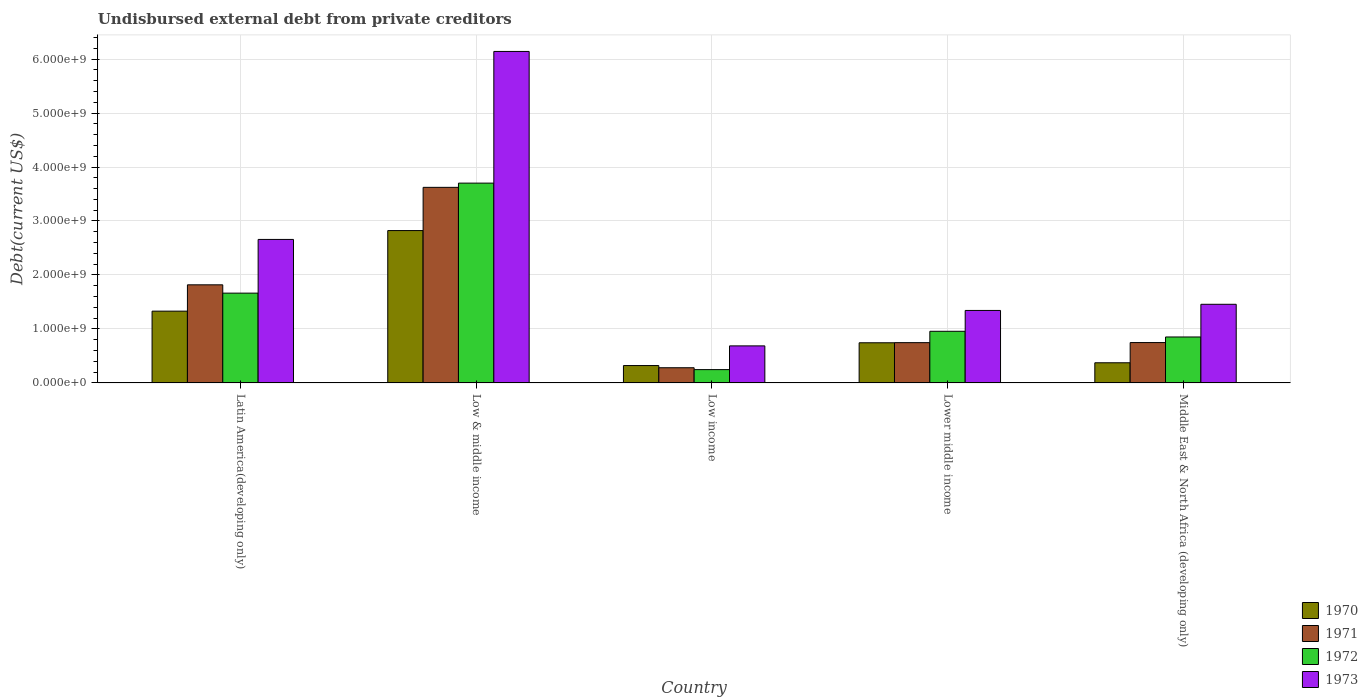How many different coloured bars are there?
Provide a succinct answer. 4. Are the number of bars per tick equal to the number of legend labels?
Your answer should be compact. Yes. How many bars are there on the 4th tick from the left?
Offer a very short reply. 4. What is the label of the 4th group of bars from the left?
Offer a terse response. Lower middle income. What is the total debt in 1971 in Middle East & North Africa (developing only)?
Your response must be concise. 7.48e+08. Across all countries, what is the maximum total debt in 1971?
Make the answer very short. 3.62e+09. Across all countries, what is the minimum total debt in 1972?
Offer a terse response. 2.47e+08. In which country was the total debt in 1970 maximum?
Make the answer very short. Low & middle income. What is the total total debt in 1972 in the graph?
Your answer should be compact. 7.42e+09. What is the difference between the total debt in 1973 in Low & middle income and that in Low income?
Your answer should be very brief. 5.45e+09. What is the difference between the total debt in 1972 in Middle East & North Africa (developing only) and the total debt in 1971 in Low & middle income?
Give a very brief answer. -2.77e+09. What is the average total debt in 1971 per country?
Provide a succinct answer. 1.44e+09. What is the difference between the total debt of/in 1971 and total debt of/in 1973 in Middle East & North Africa (developing only)?
Offer a very short reply. -7.09e+08. What is the ratio of the total debt in 1973 in Low & middle income to that in Lower middle income?
Offer a terse response. 4.57. Is the total debt in 1971 in Latin America(developing only) less than that in Low & middle income?
Your answer should be very brief. Yes. What is the difference between the highest and the second highest total debt in 1973?
Keep it short and to the point. -1.20e+09. What is the difference between the highest and the lowest total debt in 1973?
Keep it short and to the point. 5.45e+09. In how many countries, is the total debt in 1971 greater than the average total debt in 1971 taken over all countries?
Offer a very short reply. 2. Is it the case that in every country, the sum of the total debt in 1973 and total debt in 1971 is greater than the sum of total debt in 1972 and total debt in 1970?
Your answer should be compact. No. What does the 3rd bar from the left in Middle East & North Africa (developing only) represents?
Provide a short and direct response. 1972. What does the 1st bar from the right in Low income represents?
Offer a terse response. 1973. Is it the case that in every country, the sum of the total debt in 1970 and total debt in 1972 is greater than the total debt in 1971?
Make the answer very short. Yes. How many bars are there?
Ensure brevity in your answer.  20. How many countries are there in the graph?
Give a very brief answer. 5. What is the difference between two consecutive major ticks on the Y-axis?
Give a very brief answer. 1.00e+09. Are the values on the major ticks of Y-axis written in scientific E-notation?
Ensure brevity in your answer.  Yes. How are the legend labels stacked?
Provide a succinct answer. Vertical. What is the title of the graph?
Your response must be concise. Undisbursed external debt from private creditors. Does "1984" appear as one of the legend labels in the graph?
Provide a short and direct response. No. What is the label or title of the X-axis?
Your answer should be compact. Country. What is the label or title of the Y-axis?
Give a very brief answer. Debt(current US$). What is the Debt(current US$) in 1970 in Latin America(developing only)?
Your answer should be very brief. 1.33e+09. What is the Debt(current US$) of 1971 in Latin America(developing only)?
Offer a very short reply. 1.82e+09. What is the Debt(current US$) in 1972 in Latin America(developing only)?
Keep it short and to the point. 1.66e+09. What is the Debt(current US$) in 1973 in Latin America(developing only)?
Keep it short and to the point. 2.66e+09. What is the Debt(current US$) in 1970 in Low & middle income?
Offer a very short reply. 2.82e+09. What is the Debt(current US$) of 1971 in Low & middle income?
Offer a terse response. 3.62e+09. What is the Debt(current US$) of 1972 in Low & middle income?
Provide a short and direct response. 3.70e+09. What is the Debt(current US$) of 1973 in Low & middle income?
Keep it short and to the point. 6.14e+09. What is the Debt(current US$) in 1970 in Low income?
Offer a terse response. 3.22e+08. What is the Debt(current US$) of 1971 in Low income?
Keep it short and to the point. 2.82e+08. What is the Debt(current US$) in 1972 in Low income?
Provide a succinct answer. 2.47e+08. What is the Debt(current US$) in 1973 in Low income?
Your response must be concise. 6.86e+08. What is the Debt(current US$) of 1970 in Lower middle income?
Your response must be concise. 7.44e+08. What is the Debt(current US$) of 1971 in Lower middle income?
Offer a terse response. 7.46e+08. What is the Debt(current US$) of 1972 in Lower middle income?
Provide a succinct answer. 9.57e+08. What is the Debt(current US$) in 1973 in Lower middle income?
Your response must be concise. 1.34e+09. What is the Debt(current US$) in 1970 in Middle East & North Africa (developing only)?
Make the answer very short. 3.74e+08. What is the Debt(current US$) in 1971 in Middle East & North Africa (developing only)?
Provide a short and direct response. 7.48e+08. What is the Debt(current US$) of 1972 in Middle East & North Africa (developing only)?
Ensure brevity in your answer.  8.51e+08. What is the Debt(current US$) in 1973 in Middle East & North Africa (developing only)?
Make the answer very short. 1.46e+09. Across all countries, what is the maximum Debt(current US$) of 1970?
Your response must be concise. 2.82e+09. Across all countries, what is the maximum Debt(current US$) in 1971?
Provide a short and direct response. 3.62e+09. Across all countries, what is the maximum Debt(current US$) of 1972?
Your answer should be very brief. 3.70e+09. Across all countries, what is the maximum Debt(current US$) in 1973?
Ensure brevity in your answer.  6.14e+09. Across all countries, what is the minimum Debt(current US$) in 1970?
Offer a very short reply. 3.22e+08. Across all countries, what is the minimum Debt(current US$) in 1971?
Ensure brevity in your answer.  2.82e+08. Across all countries, what is the minimum Debt(current US$) of 1972?
Your answer should be compact. 2.47e+08. Across all countries, what is the minimum Debt(current US$) of 1973?
Give a very brief answer. 6.86e+08. What is the total Debt(current US$) in 1970 in the graph?
Ensure brevity in your answer.  5.59e+09. What is the total Debt(current US$) of 1971 in the graph?
Keep it short and to the point. 7.22e+09. What is the total Debt(current US$) of 1972 in the graph?
Your answer should be compact. 7.42e+09. What is the total Debt(current US$) in 1973 in the graph?
Provide a succinct answer. 1.23e+1. What is the difference between the Debt(current US$) in 1970 in Latin America(developing only) and that in Low & middle income?
Your answer should be compact. -1.49e+09. What is the difference between the Debt(current US$) in 1971 in Latin America(developing only) and that in Low & middle income?
Keep it short and to the point. -1.81e+09. What is the difference between the Debt(current US$) of 1972 in Latin America(developing only) and that in Low & middle income?
Your response must be concise. -2.04e+09. What is the difference between the Debt(current US$) of 1973 in Latin America(developing only) and that in Low & middle income?
Provide a short and direct response. -3.48e+09. What is the difference between the Debt(current US$) in 1970 in Latin America(developing only) and that in Low income?
Your response must be concise. 1.01e+09. What is the difference between the Debt(current US$) of 1971 in Latin America(developing only) and that in Low income?
Offer a very short reply. 1.54e+09. What is the difference between the Debt(current US$) of 1972 in Latin America(developing only) and that in Low income?
Make the answer very short. 1.42e+09. What is the difference between the Debt(current US$) in 1973 in Latin America(developing only) and that in Low income?
Your answer should be very brief. 1.97e+09. What is the difference between the Debt(current US$) in 1970 in Latin America(developing only) and that in Lower middle income?
Keep it short and to the point. 5.86e+08. What is the difference between the Debt(current US$) in 1971 in Latin America(developing only) and that in Lower middle income?
Your answer should be very brief. 1.07e+09. What is the difference between the Debt(current US$) in 1972 in Latin America(developing only) and that in Lower middle income?
Offer a very short reply. 7.07e+08. What is the difference between the Debt(current US$) in 1973 in Latin America(developing only) and that in Lower middle income?
Your answer should be compact. 1.32e+09. What is the difference between the Debt(current US$) of 1970 in Latin America(developing only) and that in Middle East & North Africa (developing only)?
Provide a succinct answer. 9.56e+08. What is the difference between the Debt(current US$) of 1971 in Latin America(developing only) and that in Middle East & North Africa (developing only)?
Offer a terse response. 1.07e+09. What is the difference between the Debt(current US$) of 1972 in Latin America(developing only) and that in Middle East & North Africa (developing only)?
Your answer should be compact. 8.12e+08. What is the difference between the Debt(current US$) in 1973 in Latin America(developing only) and that in Middle East & North Africa (developing only)?
Your response must be concise. 1.20e+09. What is the difference between the Debt(current US$) of 1970 in Low & middle income and that in Low income?
Your answer should be compact. 2.50e+09. What is the difference between the Debt(current US$) in 1971 in Low & middle income and that in Low income?
Make the answer very short. 3.34e+09. What is the difference between the Debt(current US$) in 1972 in Low & middle income and that in Low income?
Provide a short and direct response. 3.45e+09. What is the difference between the Debt(current US$) in 1973 in Low & middle income and that in Low income?
Offer a very short reply. 5.45e+09. What is the difference between the Debt(current US$) in 1970 in Low & middle income and that in Lower middle income?
Your answer should be compact. 2.08e+09. What is the difference between the Debt(current US$) of 1971 in Low & middle income and that in Lower middle income?
Provide a succinct answer. 2.88e+09. What is the difference between the Debt(current US$) in 1972 in Low & middle income and that in Lower middle income?
Provide a short and direct response. 2.74e+09. What is the difference between the Debt(current US$) of 1973 in Low & middle income and that in Lower middle income?
Ensure brevity in your answer.  4.80e+09. What is the difference between the Debt(current US$) in 1970 in Low & middle income and that in Middle East & North Africa (developing only)?
Make the answer very short. 2.45e+09. What is the difference between the Debt(current US$) of 1971 in Low & middle income and that in Middle East & North Africa (developing only)?
Your answer should be very brief. 2.88e+09. What is the difference between the Debt(current US$) of 1972 in Low & middle income and that in Middle East & North Africa (developing only)?
Make the answer very short. 2.85e+09. What is the difference between the Debt(current US$) of 1973 in Low & middle income and that in Middle East & North Africa (developing only)?
Your answer should be very brief. 4.68e+09. What is the difference between the Debt(current US$) in 1970 in Low income and that in Lower middle income?
Your response must be concise. -4.22e+08. What is the difference between the Debt(current US$) in 1971 in Low income and that in Lower middle income?
Ensure brevity in your answer.  -4.65e+08. What is the difference between the Debt(current US$) of 1972 in Low income and that in Lower middle income?
Give a very brief answer. -7.10e+08. What is the difference between the Debt(current US$) of 1973 in Low income and that in Lower middle income?
Keep it short and to the point. -6.56e+08. What is the difference between the Debt(current US$) of 1970 in Low income and that in Middle East & North Africa (developing only)?
Your answer should be compact. -5.15e+07. What is the difference between the Debt(current US$) in 1971 in Low income and that in Middle East & North Africa (developing only)?
Make the answer very short. -4.66e+08. What is the difference between the Debt(current US$) in 1972 in Low income and that in Middle East & North Africa (developing only)?
Ensure brevity in your answer.  -6.05e+08. What is the difference between the Debt(current US$) in 1973 in Low income and that in Middle East & North Africa (developing only)?
Ensure brevity in your answer.  -7.71e+08. What is the difference between the Debt(current US$) of 1970 in Lower middle income and that in Middle East & North Africa (developing only)?
Offer a terse response. 3.71e+08. What is the difference between the Debt(current US$) of 1971 in Lower middle income and that in Middle East & North Africa (developing only)?
Your answer should be very brief. -1.62e+06. What is the difference between the Debt(current US$) in 1972 in Lower middle income and that in Middle East & North Africa (developing only)?
Offer a terse response. 1.05e+08. What is the difference between the Debt(current US$) of 1973 in Lower middle income and that in Middle East & North Africa (developing only)?
Offer a very short reply. -1.14e+08. What is the difference between the Debt(current US$) of 1970 in Latin America(developing only) and the Debt(current US$) of 1971 in Low & middle income?
Your answer should be very brief. -2.29e+09. What is the difference between the Debt(current US$) in 1970 in Latin America(developing only) and the Debt(current US$) in 1972 in Low & middle income?
Offer a very short reply. -2.37e+09. What is the difference between the Debt(current US$) in 1970 in Latin America(developing only) and the Debt(current US$) in 1973 in Low & middle income?
Offer a very short reply. -4.81e+09. What is the difference between the Debt(current US$) in 1971 in Latin America(developing only) and the Debt(current US$) in 1972 in Low & middle income?
Provide a short and direct response. -1.88e+09. What is the difference between the Debt(current US$) in 1971 in Latin America(developing only) and the Debt(current US$) in 1973 in Low & middle income?
Offer a very short reply. -4.32e+09. What is the difference between the Debt(current US$) of 1972 in Latin America(developing only) and the Debt(current US$) of 1973 in Low & middle income?
Your response must be concise. -4.48e+09. What is the difference between the Debt(current US$) in 1970 in Latin America(developing only) and the Debt(current US$) in 1971 in Low income?
Your answer should be compact. 1.05e+09. What is the difference between the Debt(current US$) in 1970 in Latin America(developing only) and the Debt(current US$) in 1972 in Low income?
Keep it short and to the point. 1.08e+09. What is the difference between the Debt(current US$) in 1970 in Latin America(developing only) and the Debt(current US$) in 1973 in Low income?
Your answer should be very brief. 6.43e+08. What is the difference between the Debt(current US$) in 1971 in Latin America(developing only) and the Debt(current US$) in 1972 in Low income?
Offer a very short reply. 1.57e+09. What is the difference between the Debt(current US$) of 1971 in Latin America(developing only) and the Debt(current US$) of 1973 in Low income?
Offer a terse response. 1.13e+09. What is the difference between the Debt(current US$) of 1972 in Latin America(developing only) and the Debt(current US$) of 1973 in Low income?
Provide a succinct answer. 9.77e+08. What is the difference between the Debt(current US$) of 1970 in Latin America(developing only) and the Debt(current US$) of 1971 in Lower middle income?
Your answer should be compact. 5.84e+08. What is the difference between the Debt(current US$) of 1970 in Latin America(developing only) and the Debt(current US$) of 1972 in Lower middle income?
Ensure brevity in your answer.  3.73e+08. What is the difference between the Debt(current US$) in 1970 in Latin America(developing only) and the Debt(current US$) in 1973 in Lower middle income?
Offer a very short reply. -1.29e+07. What is the difference between the Debt(current US$) in 1971 in Latin America(developing only) and the Debt(current US$) in 1972 in Lower middle income?
Keep it short and to the point. 8.61e+08. What is the difference between the Debt(current US$) in 1971 in Latin America(developing only) and the Debt(current US$) in 1973 in Lower middle income?
Your response must be concise. 4.75e+08. What is the difference between the Debt(current US$) of 1972 in Latin America(developing only) and the Debt(current US$) of 1973 in Lower middle income?
Offer a terse response. 3.21e+08. What is the difference between the Debt(current US$) of 1970 in Latin America(developing only) and the Debt(current US$) of 1971 in Middle East & North Africa (developing only)?
Provide a short and direct response. 5.82e+08. What is the difference between the Debt(current US$) of 1970 in Latin America(developing only) and the Debt(current US$) of 1972 in Middle East & North Africa (developing only)?
Your answer should be compact. 4.79e+08. What is the difference between the Debt(current US$) in 1970 in Latin America(developing only) and the Debt(current US$) in 1973 in Middle East & North Africa (developing only)?
Give a very brief answer. -1.27e+08. What is the difference between the Debt(current US$) of 1971 in Latin America(developing only) and the Debt(current US$) of 1972 in Middle East & North Africa (developing only)?
Your response must be concise. 9.66e+08. What is the difference between the Debt(current US$) in 1971 in Latin America(developing only) and the Debt(current US$) in 1973 in Middle East & North Africa (developing only)?
Ensure brevity in your answer.  3.61e+08. What is the difference between the Debt(current US$) of 1972 in Latin America(developing only) and the Debt(current US$) of 1973 in Middle East & North Africa (developing only)?
Offer a terse response. 2.07e+08. What is the difference between the Debt(current US$) in 1970 in Low & middle income and the Debt(current US$) in 1971 in Low income?
Your answer should be very brief. 2.54e+09. What is the difference between the Debt(current US$) in 1970 in Low & middle income and the Debt(current US$) in 1972 in Low income?
Offer a terse response. 2.58e+09. What is the difference between the Debt(current US$) in 1970 in Low & middle income and the Debt(current US$) in 1973 in Low income?
Offer a terse response. 2.14e+09. What is the difference between the Debt(current US$) in 1971 in Low & middle income and the Debt(current US$) in 1972 in Low income?
Your answer should be compact. 3.38e+09. What is the difference between the Debt(current US$) in 1971 in Low & middle income and the Debt(current US$) in 1973 in Low income?
Your response must be concise. 2.94e+09. What is the difference between the Debt(current US$) of 1972 in Low & middle income and the Debt(current US$) of 1973 in Low income?
Offer a terse response. 3.02e+09. What is the difference between the Debt(current US$) in 1970 in Low & middle income and the Debt(current US$) in 1971 in Lower middle income?
Give a very brief answer. 2.08e+09. What is the difference between the Debt(current US$) of 1970 in Low & middle income and the Debt(current US$) of 1972 in Lower middle income?
Offer a very short reply. 1.87e+09. What is the difference between the Debt(current US$) of 1970 in Low & middle income and the Debt(current US$) of 1973 in Lower middle income?
Offer a very short reply. 1.48e+09. What is the difference between the Debt(current US$) of 1971 in Low & middle income and the Debt(current US$) of 1972 in Lower middle income?
Provide a succinct answer. 2.67e+09. What is the difference between the Debt(current US$) in 1971 in Low & middle income and the Debt(current US$) in 1973 in Lower middle income?
Give a very brief answer. 2.28e+09. What is the difference between the Debt(current US$) of 1972 in Low & middle income and the Debt(current US$) of 1973 in Lower middle income?
Give a very brief answer. 2.36e+09. What is the difference between the Debt(current US$) of 1970 in Low & middle income and the Debt(current US$) of 1971 in Middle East & North Africa (developing only)?
Offer a very short reply. 2.07e+09. What is the difference between the Debt(current US$) of 1970 in Low & middle income and the Debt(current US$) of 1972 in Middle East & North Africa (developing only)?
Provide a succinct answer. 1.97e+09. What is the difference between the Debt(current US$) in 1970 in Low & middle income and the Debt(current US$) in 1973 in Middle East & North Africa (developing only)?
Provide a short and direct response. 1.37e+09. What is the difference between the Debt(current US$) of 1971 in Low & middle income and the Debt(current US$) of 1972 in Middle East & North Africa (developing only)?
Your answer should be very brief. 2.77e+09. What is the difference between the Debt(current US$) of 1971 in Low & middle income and the Debt(current US$) of 1973 in Middle East & North Africa (developing only)?
Ensure brevity in your answer.  2.17e+09. What is the difference between the Debt(current US$) of 1972 in Low & middle income and the Debt(current US$) of 1973 in Middle East & North Africa (developing only)?
Provide a succinct answer. 2.24e+09. What is the difference between the Debt(current US$) in 1970 in Low income and the Debt(current US$) in 1971 in Lower middle income?
Your answer should be very brief. -4.24e+08. What is the difference between the Debt(current US$) in 1970 in Low income and the Debt(current US$) in 1972 in Lower middle income?
Ensure brevity in your answer.  -6.35e+08. What is the difference between the Debt(current US$) of 1970 in Low income and the Debt(current US$) of 1973 in Lower middle income?
Provide a short and direct response. -1.02e+09. What is the difference between the Debt(current US$) in 1971 in Low income and the Debt(current US$) in 1972 in Lower middle income?
Offer a very short reply. -6.75e+08. What is the difference between the Debt(current US$) of 1971 in Low income and the Debt(current US$) of 1973 in Lower middle income?
Your answer should be compact. -1.06e+09. What is the difference between the Debt(current US$) of 1972 in Low income and the Debt(current US$) of 1973 in Lower middle income?
Provide a succinct answer. -1.10e+09. What is the difference between the Debt(current US$) in 1970 in Low income and the Debt(current US$) in 1971 in Middle East & North Africa (developing only)?
Give a very brief answer. -4.26e+08. What is the difference between the Debt(current US$) of 1970 in Low income and the Debt(current US$) of 1972 in Middle East & North Africa (developing only)?
Give a very brief answer. -5.29e+08. What is the difference between the Debt(current US$) of 1970 in Low income and the Debt(current US$) of 1973 in Middle East & North Africa (developing only)?
Give a very brief answer. -1.13e+09. What is the difference between the Debt(current US$) in 1971 in Low income and the Debt(current US$) in 1972 in Middle East & North Africa (developing only)?
Your response must be concise. -5.70e+08. What is the difference between the Debt(current US$) in 1971 in Low income and the Debt(current US$) in 1973 in Middle East & North Africa (developing only)?
Offer a very short reply. -1.18e+09. What is the difference between the Debt(current US$) of 1972 in Low income and the Debt(current US$) of 1973 in Middle East & North Africa (developing only)?
Give a very brief answer. -1.21e+09. What is the difference between the Debt(current US$) of 1970 in Lower middle income and the Debt(current US$) of 1971 in Middle East & North Africa (developing only)?
Provide a short and direct response. -3.71e+06. What is the difference between the Debt(current US$) in 1970 in Lower middle income and the Debt(current US$) in 1972 in Middle East & North Africa (developing only)?
Give a very brief answer. -1.07e+08. What is the difference between the Debt(current US$) in 1970 in Lower middle income and the Debt(current US$) in 1973 in Middle East & North Africa (developing only)?
Provide a short and direct response. -7.13e+08. What is the difference between the Debt(current US$) in 1971 in Lower middle income and the Debt(current US$) in 1972 in Middle East & North Africa (developing only)?
Provide a short and direct response. -1.05e+08. What is the difference between the Debt(current US$) of 1971 in Lower middle income and the Debt(current US$) of 1973 in Middle East & North Africa (developing only)?
Your answer should be very brief. -7.11e+08. What is the difference between the Debt(current US$) of 1972 in Lower middle income and the Debt(current US$) of 1973 in Middle East & North Africa (developing only)?
Your answer should be very brief. -5.00e+08. What is the average Debt(current US$) in 1970 per country?
Offer a terse response. 1.12e+09. What is the average Debt(current US$) of 1971 per country?
Provide a succinct answer. 1.44e+09. What is the average Debt(current US$) of 1972 per country?
Offer a very short reply. 1.48e+09. What is the average Debt(current US$) in 1973 per country?
Your answer should be compact. 2.46e+09. What is the difference between the Debt(current US$) in 1970 and Debt(current US$) in 1971 in Latin America(developing only)?
Offer a very short reply. -4.88e+08. What is the difference between the Debt(current US$) of 1970 and Debt(current US$) of 1972 in Latin America(developing only)?
Your answer should be compact. -3.34e+08. What is the difference between the Debt(current US$) in 1970 and Debt(current US$) in 1973 in Latin America(developing only)?
Give a very brief answer. -1.33e+09. What is the difference between the Debt(current US$) of 1971 and Debt(current US$) of 1972 in Latin America(developing only)?
Offer a very short reply. 1.54e+08. What is the difference between the Debt(current US$) of 1971 and Debt(current US$) of 1973 in Latin America(developing only)?
Keep it short and to the point. -8.41e+08. What is the difference between the Debt(current US$) in 1972 and Debt(current US$) in 1973 in Latin America(developing only)?
Offer a terse response. -9.95e+08. What is the difference between the Debt(current US$) in 1970 and Debt(current US$) in 1971 in Low & middle income?
Provide a succinct answer. -8.01e+08. What is the difference between the Debt(current US$) in 1970 and Debt(current US$) in 1972 in Low & middle income?
Your answer should be compact. -8.79e+08. What is the difference between the Debt(current US$) in 1970 and Debt(current US$) in 1973 in Low & middle income?
Your response must be concise. -3.32e+09. What is the difference between the Debt(current US$) in 1971 and Debt(current US$) in 1972 in Low & middle income?
Provide a succinct answer. -7.84e+07. What is the difference between the Debt(current US$) of 1971 and Debt(current US$) of 1973 in Low & middle income?
Give a very brief answer. -2.52e+09. What is the difference between the Debt(current US$) of 1972 and Debt(current US$) of 1973 in Low & middle income?
Ensure brevity in your answer.  -2.44e+09. What is the difference between the Debt(current US$) in 1970 and Debt(current US$) in 1971 in Low income?
Provide a short and direct response. 4.06e+07. What is the difference between the Debt(current US$) of 1970 and Debt(current US$) of 1972 in Low income?
Ensure brevity in your answer.  7.53e+07. What is the difference between the Debt(current US$) in 1970 and Debt(current US$) in 1973 in Low income?
Give a very brief answer. -3.64e+08. What is the difference between the Debt(current US$) in 1971 and Debt(current US$) in 1972 in Low income?
Ensure brevity in your answer.  3.47e+07. What is the difference between the Debt(current US$) in 1971 and Debt(current US$) in 1973 in Low income?
Ensure brevity in your answer.  -4.05e+08. What is the difference between the Debt(current US$) of 1972 and Debt(current US$) of 1973 in Low income?
Your response must be concise. -4.40e+08. What is the difference between the Debt(current US$) in 1970 and Debt(current US$) in 1971 in Lower middle income?
Offer a very short reply. -2.10e+06. What is the difference between the Debt(current US$) of 1970 and Debt(current US$) of 1972 in Lower middle income?
Your answer should be very brief. -2.13e+08. What is the difference between the Debt(current US$) in 1970 and Debt(current US$) in 1973 in Lower middle income?
Make the answer very short. -5.99e+08. What is the difference between the Debt(current US$) of 1971 and Debt(current US$) of 1972 in Lower middle income?
Make the answer very short. -2.11e+08. What is the difference between the Debt(current US$) of 1971 and Debt(current US$) of 1973 in Lower middle income?
Provide a short and direct response. -5.97e+08. What is the difference between the Debt(current US$) of 1972 and Debt(current US$) of 1973 in Lower middle income?
Offer a very short reply. -3.86e+08. What is the difference between the Debt(current US$) in 1970 and Debt(current US$) in 1971 in Middle East & North Africa (developing only)?
Your response must be concise. -3.74e+08. What is the difference between the Debt(current US$) of 1970 and Debt(current US$) of 1972 in Middle East & North Africa (developing only)?
Ensure brevity in your answer.  -4.78e+08. What is the difference between the Debt(current US$) of 1970 and Debt(current US$) of 1973 in Middle East & North Africa (developing only)?
Your answer should be very brief. -1.08e+09. What is the difference between the Debt(current US$) in 1971 and Debt(current US$) in 1972 in Middle East & North Africa (developing only)?
Your answer should be very brief. -1.04e+08. What is the difference between the Debt(current US$) in 1971 and Debt(current US$) in 1973 in Middle East & North Africa (developing only)?
Keep it short and to the point. -7.09e+08. What is the difference between the Debt(current US$) of 1972 and Debt(current US$) of 1973 in Middle East & North Africa (developing only)?
Your answer should be very brief. -6.06e+08. What is the ratio of the Debt(current US$) of 1970 in Latin America(developing only) to that in Low & middle income?
Offer a terse response. 0.47. What is the ratio of the Debt(current US$) in 1971 in Latin America(developing only) to that in Low & middle income?
Make the answer very short. 0.5. What is the ratio of the Debt(current US$) in 1972 in Latin America(developing only) to that in Low & middle income?
Make the answer very short. 0.45. What is the ratio of the Debt(current US$) in 1973 in Latin America(developing only) to that in Low & middle income?
Your response must be concise. 0.43. What is the ratio of the Debt(current US$) of 1970 in Latin America(developing only) to that in Low income?
Offer a terse response. 4.13. What is the ratio of the Debt(current US$) in 1971 in Latin America(developing only) to that in Low income?
Provide a short and direct response. 6.46. What is the ratio of the Debt(current US$) of 1972 in Latin America(developing only) to that in Low income?
Your answer should be compact. 6.74. What is the ratio of the Debt(current US$) of 1973 in Latin America(developing only) to that in Low income?
Give a very brief answer. 3.87. What is the ratio of the Debt(current US$) of 1970 in Latin America(developing only) to that in Lower middle income?
Provide a succinct answer. 1.79. What is the ratio of the Debt(current US$) in 1971 in Latin America(developing only) to that in Lower middle income?
Your answer should be very brief. 2.44. What is the ratio of the Debt(current US$) of 1972 in Latin America(developing only) to that in Lower middle income?
Your answer should be very brief. 1.74. What is the ratio of the Debt(current US$) of 1973 in Latin America(developing only) to that in Lower middle income?
Keep it short and to the point. 1.98. What is the ratio of the Debt(current US$) of 1970 in Latin America(developing only) to that in Middle East & North Africa (developing only)?
Ensure brevity in your answer.  3.56. What is the ratio of the Debt(current US$) of 1971 in Latin America(developing only) to that in Middle East & North Africa (developing only)?
Provide a short and direct response. 2.43. What is the ratio of the Debt(current US$) in 1972 in Latin America(developing only) to that in Middle East & North Africa (developing only)?
Your answer should be very brief. 1.95. What is the ratio of the Debt(current US$) in 1973 in Latin America(developing only) to that in Middle East & North Africa (developing only)?
Keep it short and to the point. 1.82. What is the ratio of the Debt(current US$) of 1970 in Low & middle income to that in Low income?
Provide a short and direct response. 8.76. What is the ratio of the Debt(current US$) of 1971 in Low & middle income to that in Low income?
Offer a very short reply. 12.87. What is the ratio of the Debt(current US$) in 1972 in Low & middle income to that in Low income?
Your response must be concise. 15. What is the ratio of the Debt(current US$) in 1973 in Low & middle income to that in Low income?
Provide a short and direct response. 8.95. What is the ratio of the Debt(current US$) of 1970 in Low & middle income to that in Lower middle income?
Provide a short and direct response. 3.79. What is the ratio of the Debt(current US$) in 1971 in Low & middle income to that in Lower middle income?
Make the answer very short. 4.86. What is the ratio of the Debt(current US$) of 1972 in Low & middle income to that in Lower middle income?
Your response must be concise. 3.87. What is the ratio of the Debt(current US$) of 1973 in Low & middle income to that in Lower middle income?
Your response must be concise. 4.57. What is the ratio of the Debt(current US$) of 1970 in Low & middle income to that in Middle East & North Africa (developing only)?
Ensure brevity in your answer.  7.55. What is the ratio of the Debt(current US$) in 1971 in Low & middle income to that in Middle East & North Africa (developing only)?
Provide a succinct answer. 4.84. What is the ratio of the Debt(current US$) of 1972 in Low & middle income to that in Middle East & North Africa (developing only)?
Ensure brevity in your answer.  4.35. What is the ratio of the Debt(current US$) of 1973 in Low & middle income to that in Middle East & North Africa (developing only)?
Ensure brevity in your answer.  4.21. What is the ratio of the Debt(current US$) of 1970 in Low income to that in Lower middle income?
Provide a succinct answer. 0.43. What is the ratio of the Debt(current US$) of 1971 in Low income to that in Lower middle income?
Make the answer very short. 0.38. What is the ratio of the Debt(current US$) in 1972 in Low income to that in Lower middle income?
Offer a very short reply. 0.26. What is the ratio of the Debt(current US$) of 1973 in Low income to that in Lower middle income?
Provide a succinct answer. 0.51. What is the ratio of the Debt(current US$) in 1970 in Low income to that in Middle East & North Africa (developing only)?
Your answer should be very brief. 0.86. What is the ratio of the Debt(current US$) of 1971 in Low income to that in Middle East & North Africa (developing only)?
Provide a short and direct response. 0.38. What is the ratio of the Debt(current US$) of 1972 in Low income to that in Middle East & North Africa (developing only)?
Ensure brevity in your answer.  0.29. What is the ratio of the Debt(current US$) of 1973 in Low income to that in Middle East & North Africa (developing only)?
Make the answer very short. 0.47. What is the ratio of the Debt(current US$) in 1970 in Lower middle income to that in Middle East & North Africa (developing only)?
Your answer should be very brief. 1.99. What is the ratio of the Debt(current US$) of 1972 in Lower middle income to that in Middle East & North Africa (developing only)?
Your response must be concise. 1.12. What is the ratio of the Debt(current US$) in 1973 in Lower middle income to that in Middle East & North Africa (developing only)?
Provide a succinct answer. 0.92. What is the difference between the highest and the second highest Debt(current US$) of 1970?
Keep it short and to the point. 1.49e+09. What is the difference between the highest and the second highest Debt(current US$) of 1971?
Your response must be concise. 1.81e+09. What is the difference between the highest and the second highest Debt(current US$) in 1972?
Provide a succinct answer. 2.04e+09. What is the difference between the highest and the second highest Debt(current US$) of 1973?
Make the answer very short. 3.48e+09. What is the difference between the highest and the lowest Debt(current US$) of 1970?
Offer a very short reply. 2.50e+09. What is the difference between the highest and the lowest Debt(current US$) in 1971?
Your response must be concise. 3.34e+09. What is the difference between the highest and the lowest Debt(current US$) of 1972?
Provide a succinct answer. 3.45e+09. What is the difference between the highest and the lowest Debt(current US$) in 1973?
Your answer should be very brief. 5.45e+09. 